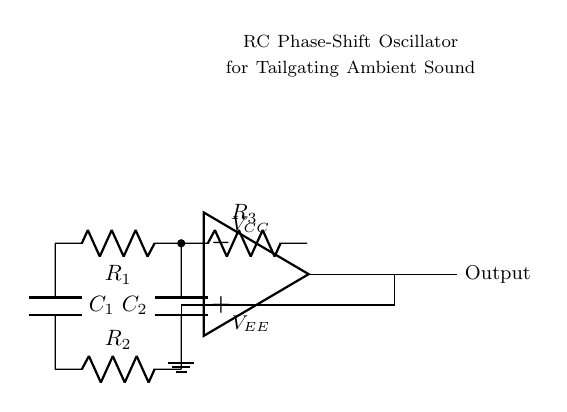What type of oscillator is this circuit? This circuit is an RC phase-shift oscillator, as indicated by the use of resistors and capacitors to create the necessary phase shifts for oscillation.
Answer: RC phase-shift What are the values of the resistors used in the circuit? The circuit contains three resistors labeled as R1, R2, and R3, but their individual values are not specified in the diagram.
Answer: Not specified How many capacitors are in the circuit? The circuit contains two capacitors, C1 and C2, which are used to help achieve the desired phase shift for oscillation.
Answer: Two What is the output of the circuit? The output of the oscillator is represented on the right side of the op-amp, labeled as "Output," indicating where the generated sound signal is available.
Answer: Output What does the op-amp do in this circuit? The op-amp functions as the amplifying component of the oscillator circuit, producing the required gain for oscillation based on the input from the resistors and capacitors.
Answer: Amplifier How does the phase shift occur in this oscillator? The phase shift occurs due to the combination of resistors and capacitors in the feedback loop, which introduces a delay that allows the circuit to oscillate at a specific frequency determined by the component values.
Answer: Through feedback What is the purpose of this oscillator in a tailgating setup? The purpose of this oscillator is to generate ambient sound effects, enhancing the tailgating experience by providing background noise or music.
Answer: Ambient sound effects 